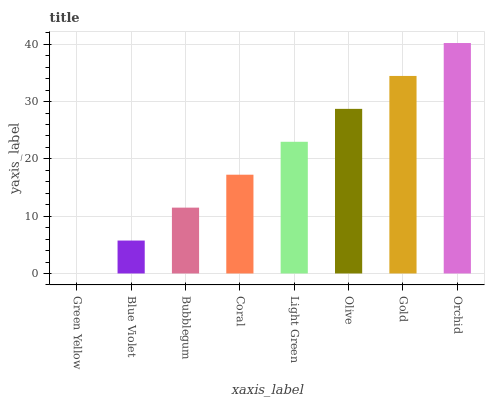Is Green Yellow the minimum?
Answer yes or no. Yes. Is Orchid the maximum?
Answer yes or no. Yes. Is Blue Violet the minimum?
Answer yes or no. No. Is Blue Violet the maximum?
Answer yes or no. No. Is Blue Violet greater than Green Yellow?
Answer yes or no. Yes. Is Green Yellow less than Blue Violet?
Answer yes or no. Yes. Is Green Yellow greater than Blue Violet?
Answer yes or no. No. Is Blue Violet less than Green Yellow?
Answer yes or no. No. Is Light Green the high median?
Answer yes or no. Yes. Is Coral the low median?
Answer yes or no. Yes. Is Bubblegum the high median?
Answer yes or no. No. Is Light Green the low median?
Answer yes or no. No. 